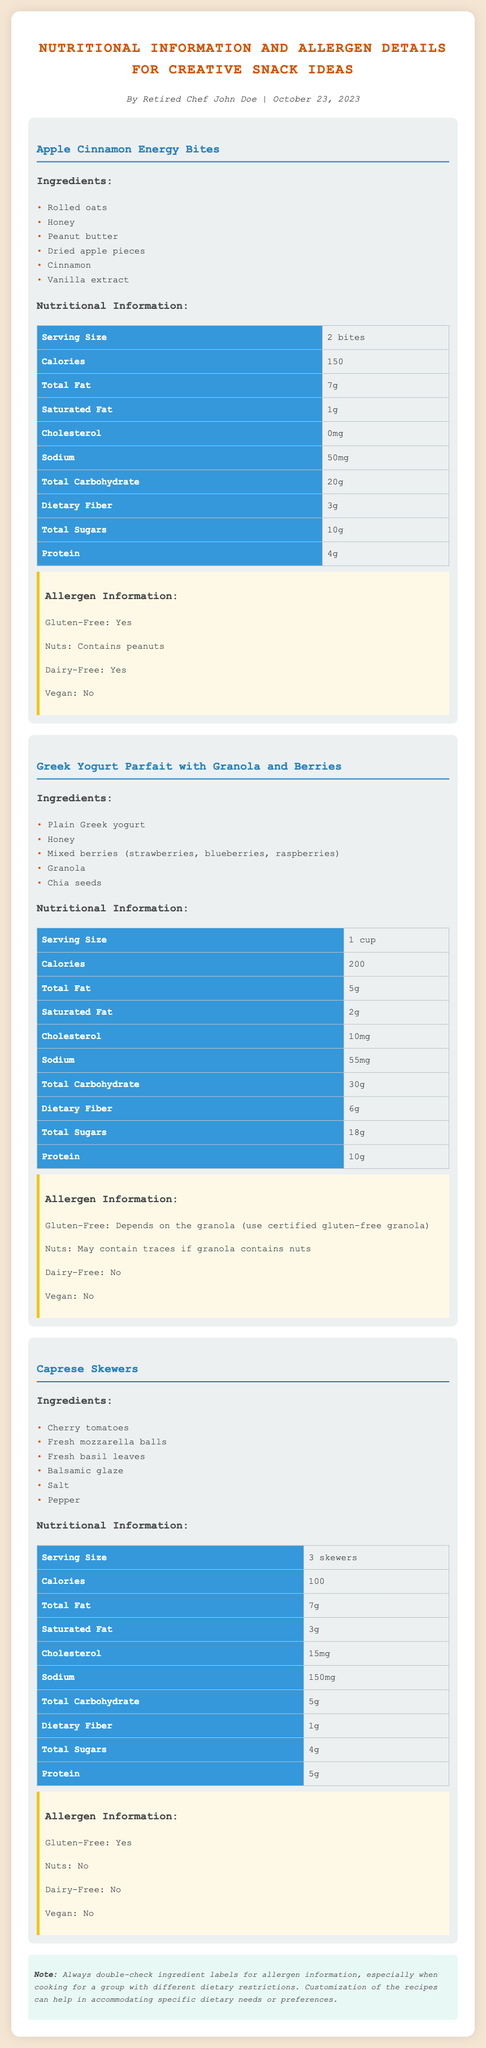what are the ingredients in Apple Cinnamon Energy Bites? The ingredients for Apple Cinnamon Energy Bites are listed as rolled oats, honey, peanut butter, dried apple pieces, cinnamon, and vanilla extract.
Answer: rolled oats, honey, peanut butter, dried apple pieces, cinnamon, vanilla extract how many calories are in the Greek Yogurt Parfait? The document specifies that the Greek Yogurt Parfait contains 200 calories per serving.
Answer: 200 is the Caprese Skewers recipe gluten-free? The allergen information states that the Caprese Skewers are gluten-free.
Answer: Yes which snack contains peanuts? According to the allergen information, the Apple Cinnamon Energy Bites contain peanuts.
Answer: Apple Cinnamon Energy Bites how much protein is in 3 skewers of Caprese Skewers? The nutritional information shows that there are 5 grams of protein in 3 skewers of Caprese Skewers.
Answer: 5g is the Greek Yogurt Parfait vegan? The allergen information indicates that the Greek Yogurt Parfait is not vegan.
Answer: No what is the total fat content of the Apple Cinnamon Energy Bites? The total fat content for Apple Cinnamon Energy Bites is listed as 7 grams.
Answer: 7g what type of document is this? This document is a product specification sheet providing nutritional and allergen details for snack recipes.
Answer: product specification sheet 